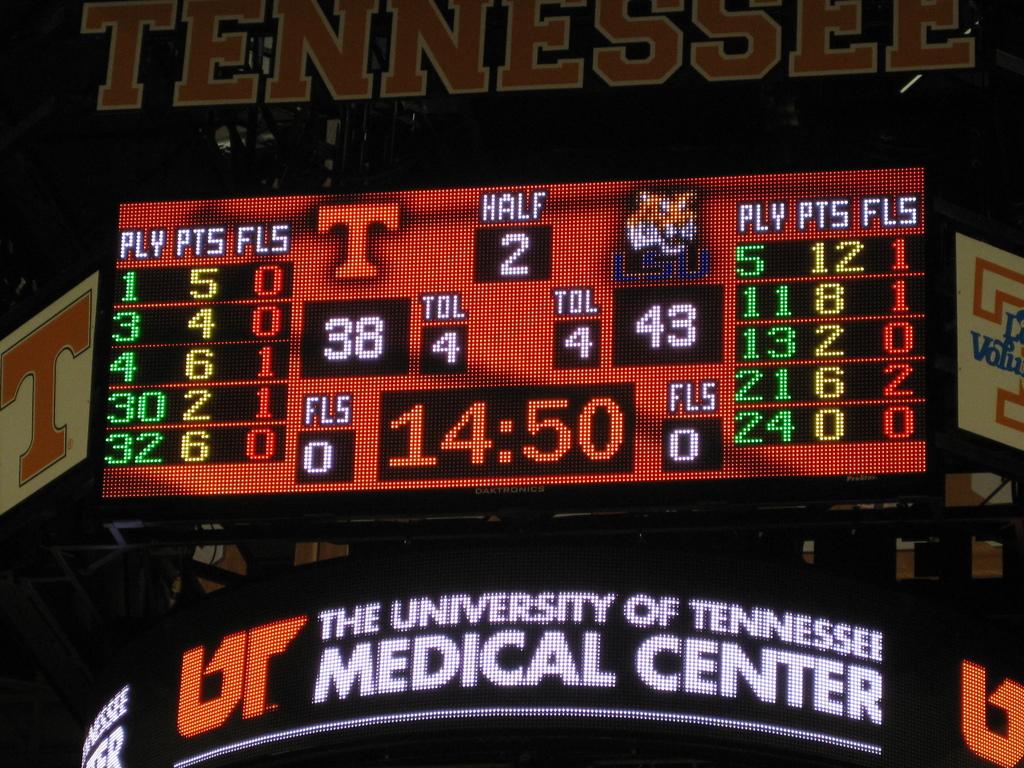How much time is left in the half?
Offer a very short reply. 14:50. What city is ut medical center located in ?
Give a very brief answer. Unanswerable. 